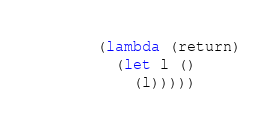Convert code to text. <code><loc_0><loc_0><loc_500><loc_500><_Scheme_>   (lambda (return)
     (let l ()
       (l)))))
</code> 